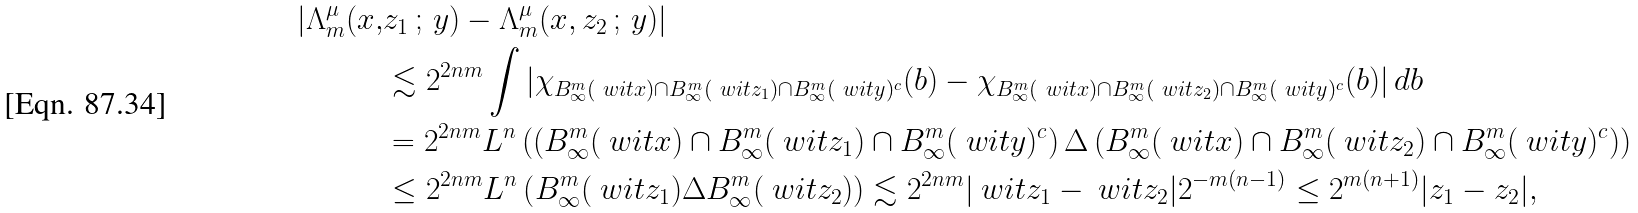Convert formula to latex. <formula><loc_0><loc_0><loc_500><loc_500>| \Lambda _ { m } ^ { \mu } ( x , & z _ { 1 } \, ; \, y ) - \Lambda _ { m } ^ { \mu } ( x , z _ { 2 } \, ; \, y ) | \\ & \lesssim 2 ^ { 2 n m } \int | \chi _ { B _ { \infty } ^ { m } ( \ w i t { x } ) \cap B _ { \infty } ^ { m } ( \ w i t { z _ { 1 } } ) \cap B _ { \infty } ^ { m } ( \ w i t { y } ) ^ { c } } ( b ) - \chi _ { B _ { \infty } ^ { m } ( \ w i t { x } ) \cap B _ { \infty } ^ { m } ( \ w i t { z _ { 2 } } ) \cap B _ { \infty } ^ { m } ( \ w i t { y } ) ^ { c } } ( b ) | \, d b \\ & = 2 ^ { 2 n m } \L L ^ { n } \left ( \left ( B _ { \infty } ^ { m } ( \ w i t { x } ) \cap B _ { \infty } ^ { m } ( \ w i t { z _ { 1 } } ) \cap B _ { \infty } ^ { m } ( \ w i t { y } ) ^ { c } \right ) \Delta \left ( B _ { \infty } ^ { m } ( \ w i t { x } ) \cap B _ { \infty } ^ { m } ( \ w i t { z _ { 2 } } ) \cap B _ { \infty } ^ { m } ( \ w i t { y } ) ^ { c } \right ) \right ) \\ & \leq 2 ^ { 2 n m } \L L ^ { n } \left ( B _ { \infty } ^ { m } ( \ w i t { z _ { 1 } } ) \Delta B _ { \infty } ^ { m } ( \ w i t { z _ { 2 } } ) \right ) \lesssim 2 ^ { 2 n m } | \ w i t { z _ { 1 } } - \ w i t { z _ { 2 } } | 2 ^ { - m ( n - 1 ) } \leq 2 ^ { m ( n + 1 ) } | z _ { 1 } - z _ { 2 } | ,</formula> 